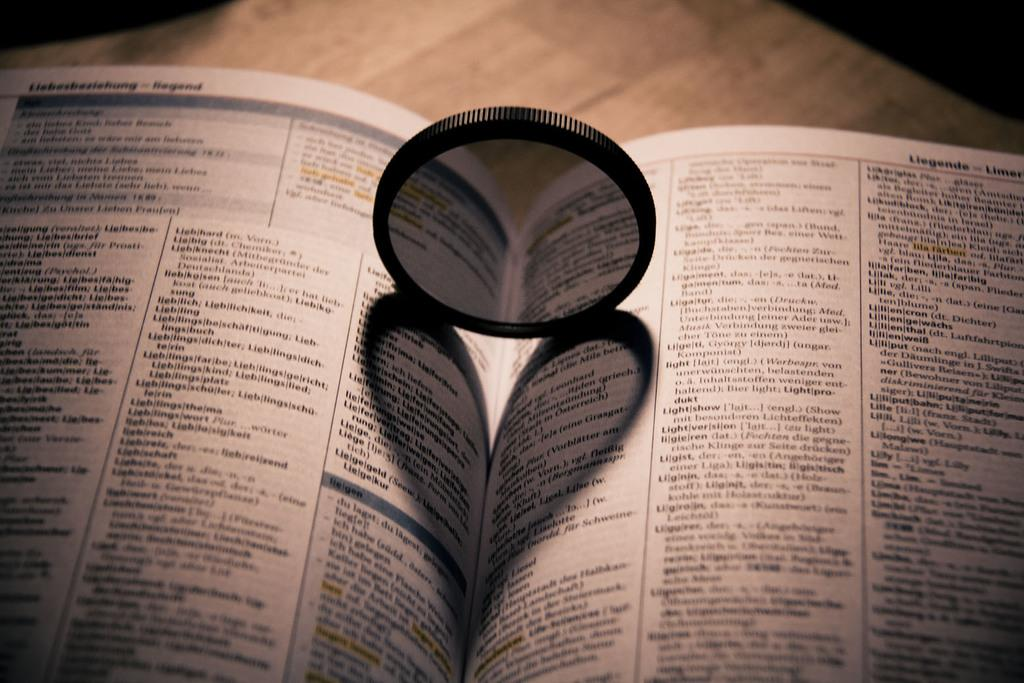<image>
Summarize the visual content of the image. A book is open to the L section of definitions. 